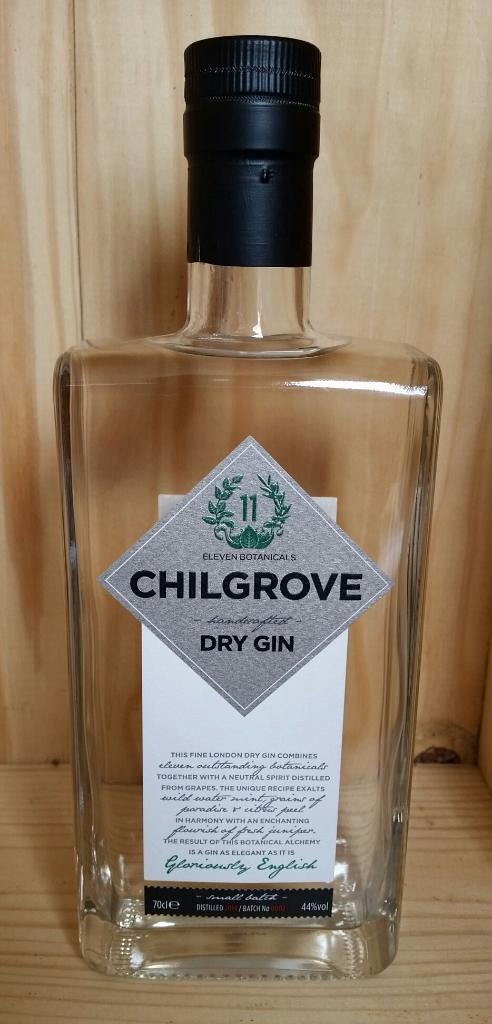<image>
Give a short and clear explanation of the subsequent image. A bottle of Chilgrove Dry Gin stands in a wooden display 